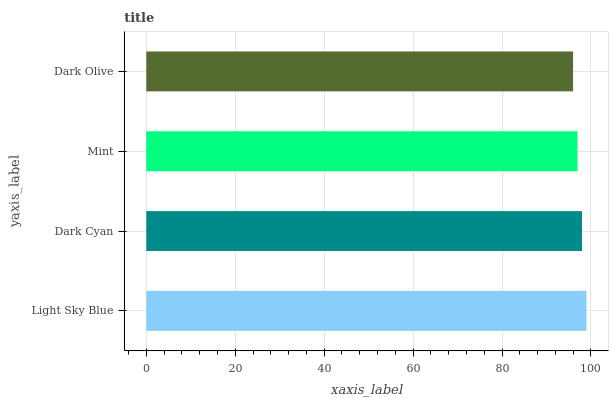Is Dark Olive the minimum?
Answer yes or no. Yes. Is Light Sky Blue the maximum?
Answer yes or no. Yes. Is Dark Cyan the minimum?
Answer yes or no. No. Is Dark Cyan the maximum?
Answer yes or no. No. Is Light Sky Blue greater than Dark Cyan?
Answer yes or no. Yes. Is Dark Cyan less than Light Sky Blue?
Answer yes or no. Yes. Is Dark Cyan greater than Light Sky Blue?
Answer yes or no. No. Is Light Sky Blue less than Dark Cyan?
Answer yes or no. No. Is Dark Cyan the high median?
Answer yes or no. Yes. Is Mint the low median?
Answer yes or no. Yes. Is Mint the high median?
Answer yes or no. No. Is Dark Cyan the low median?
Answer yes or no. No. 